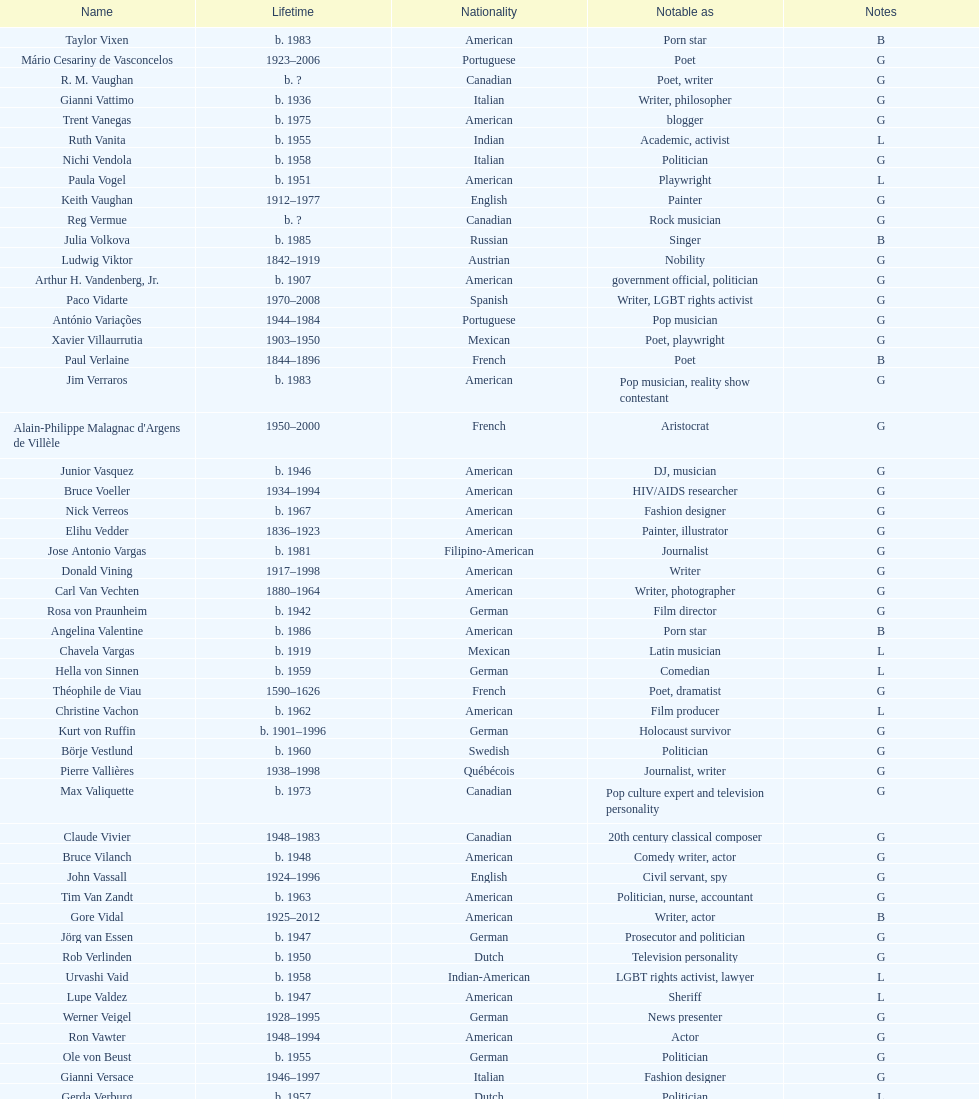Who lived longer, van vechten or variacoes? Van Vechten. 